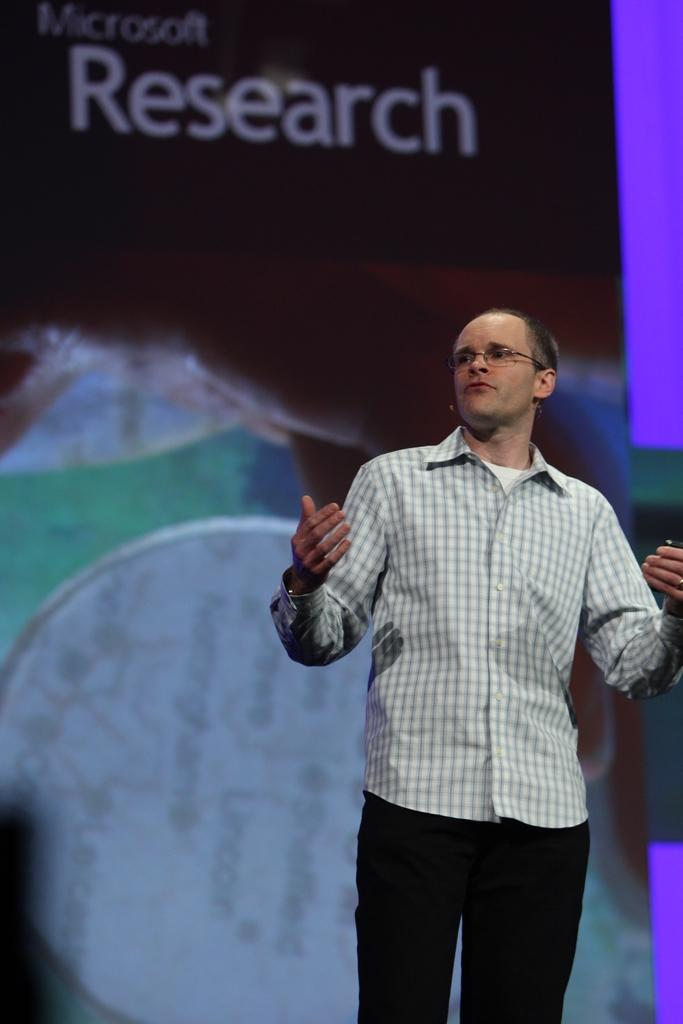What is the position of the man in the image? The man is standing on the right side of the image. What can be seen on the man's face in the image? The man is wearing spectacles in the image. What is present in the background of the image? There is a board in the background of the image. What type of steel beam is supporting the board in the image? There is no steel beam visible in the image, and the board's support is not mentioned in the provided facts. 